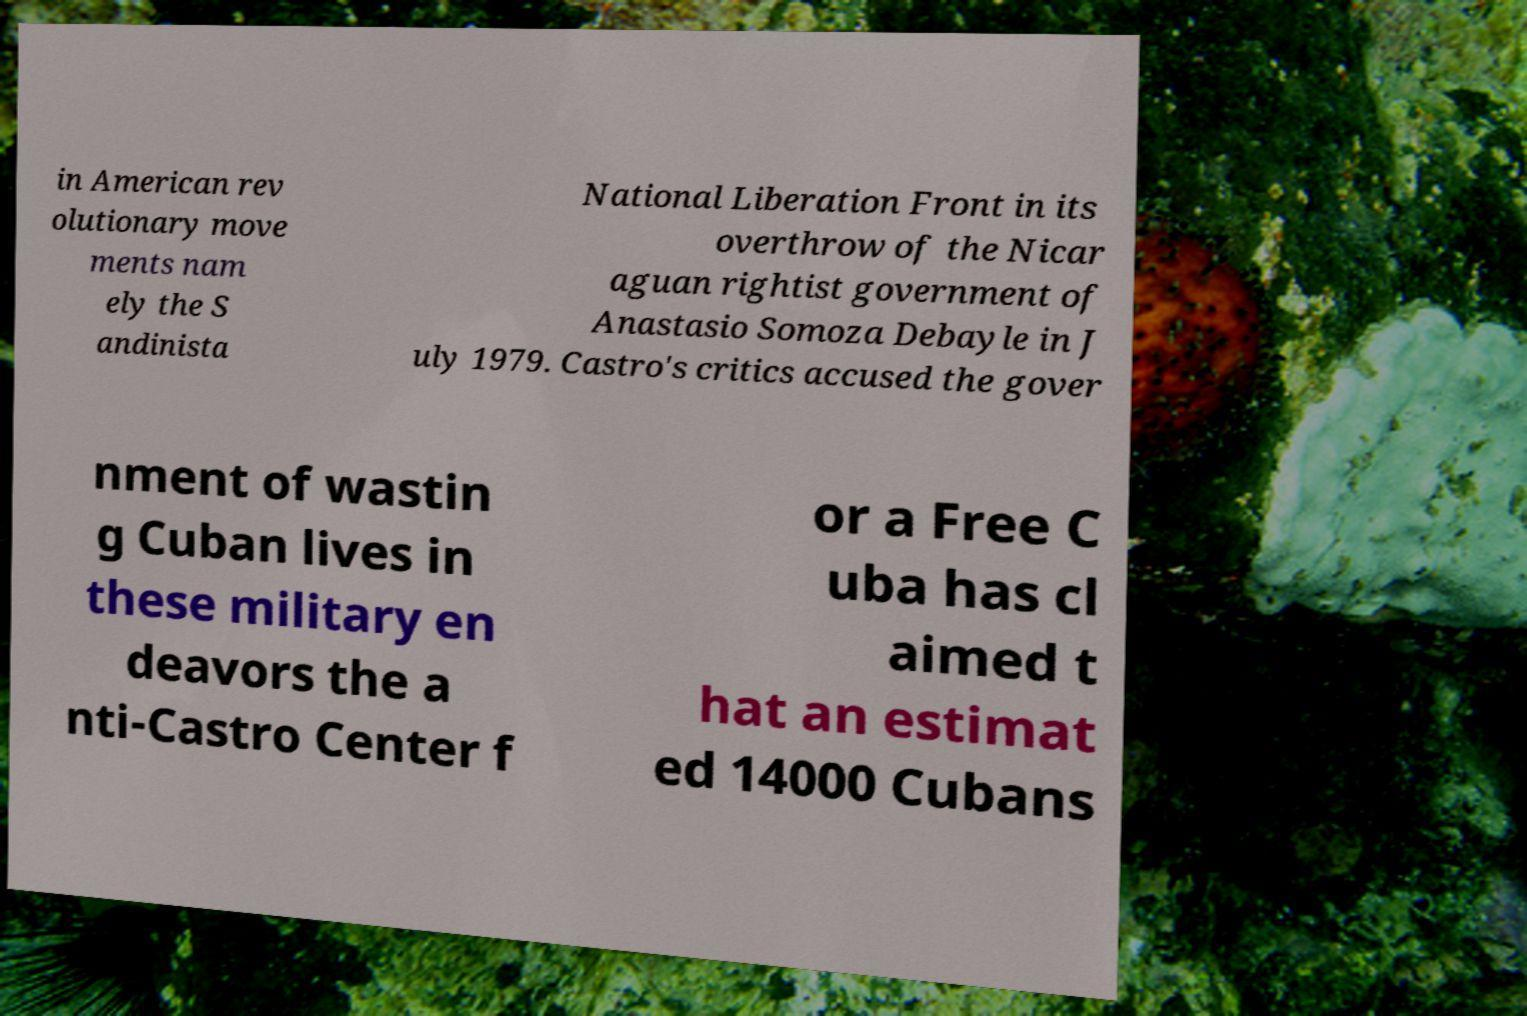I need the written content from this picture converted into text. Can you do that? in American rev olutionary move ments nam ely the S andinista National Liberation Front in its overthrow of the Nicar aguan rightist government of Anastasio Somoza Debayle in J uly 1979. Castro's critics accused the gover nment of wastin g Cuban lives in these military en deavors the a nti-Castro Center f or a Free C uba has cl aimed t hat an estimat ed 14000 Cubans 